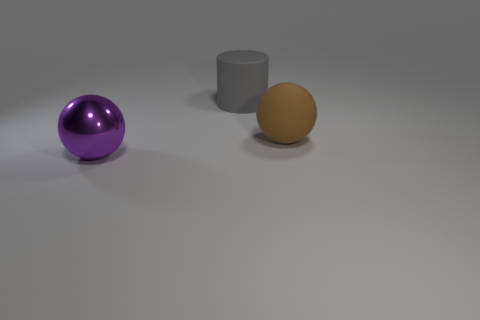Subtract all purple balls. How many balls are left? 1 Subtract 0 yellow blocks. How many objects are left? 3 Subtract all balls. How many objects are left? 1 Subtract all red spheres. Subtract all green cubes. How many spheres are left? 2 Subtract all blue cubes. How many purple spheres are left? 1 Subtract all big purple metallic cubes. Subtract all rubber things. How many objects are left? 1 Add 1 purple things. How many purple things are left? 2 Add 1 large gray rubber cylinders. How many large gray rubber cylinders exist? 2 Add 3 metal spheres. How many objects exist? 6 